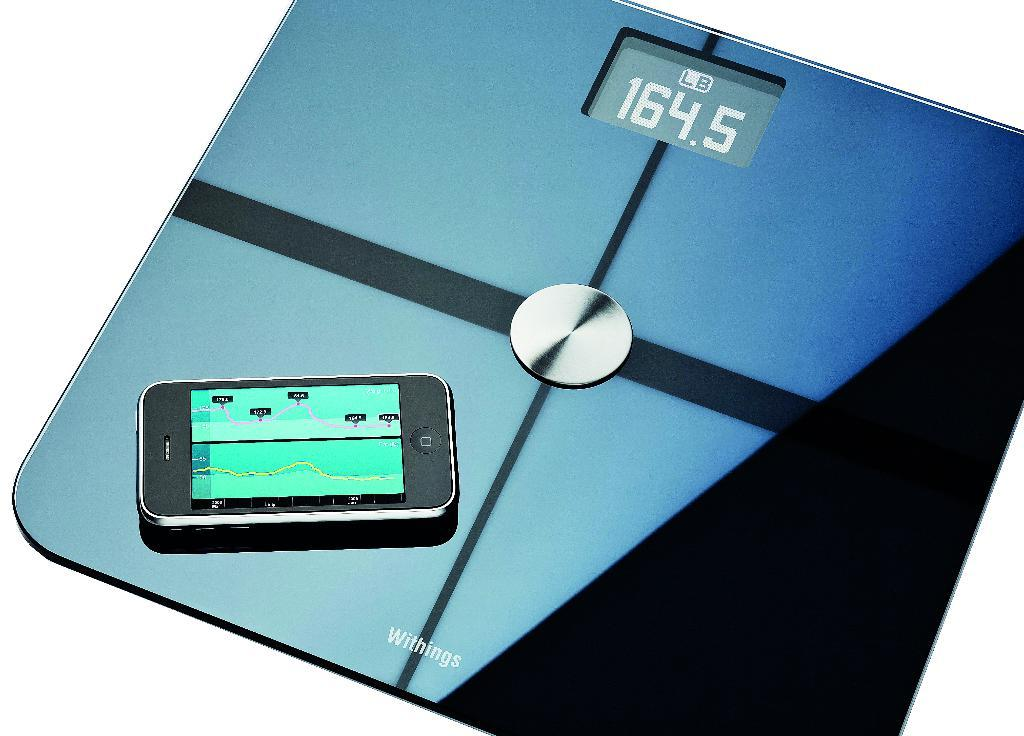<image>
Describe the image concisely. A cell phone sitting on a Withings scale with a read out of 164.5. 